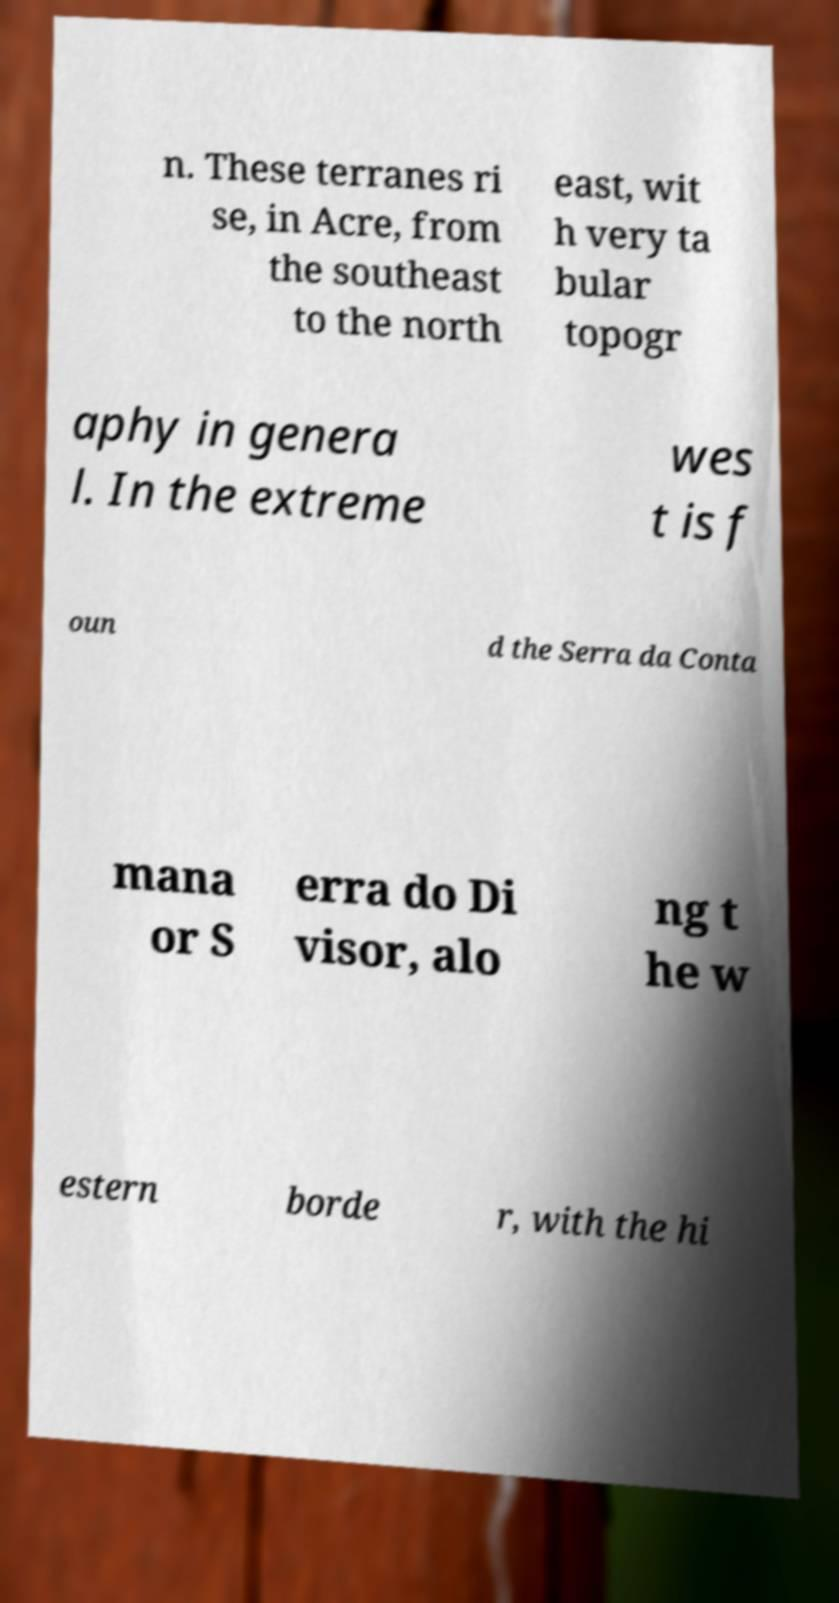For documentation purposes, I need the text within this image transcribed. Could you provide that? n. These terranes ri se, in Acre, from the southeast to the north east, wit h very ta bular topogr aphy in genera l. In the extreme wes t is f oun d the Serra da Conta mana or S erra do Di visor, alo ng t he w estern borde r, with the hi 